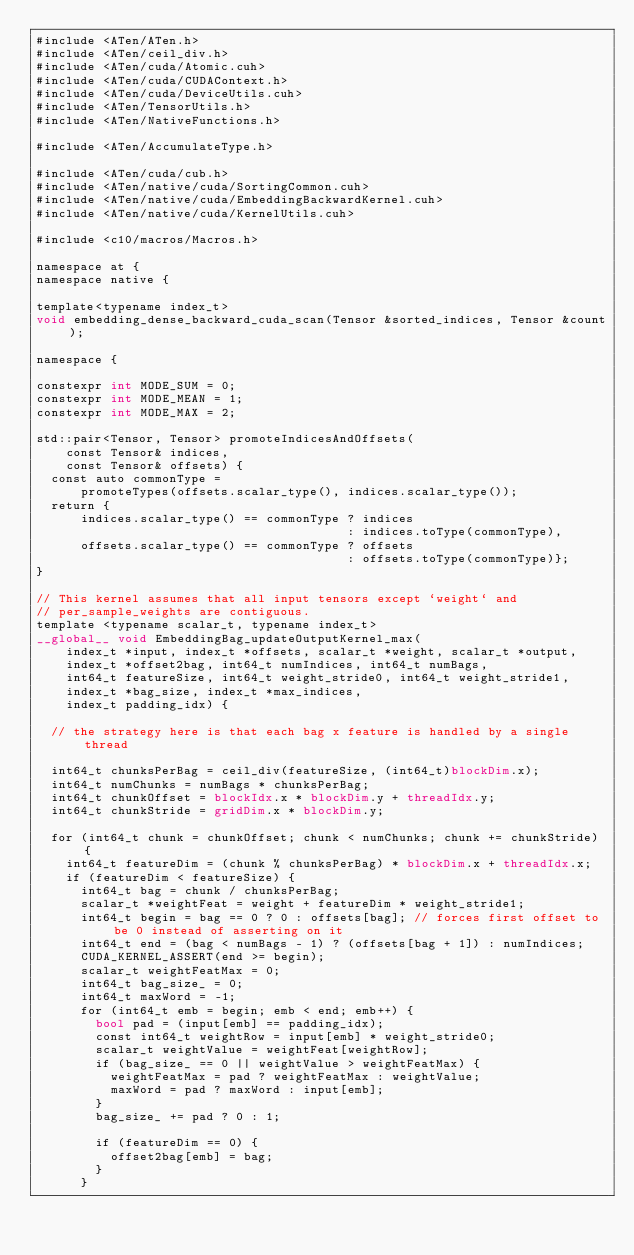<code> <loc_0><loc_0><loc_500><loc_500><_Cuda_>#include <ATen/ATen.h>
#include <ATen/ceil_div.h>
#include <ATen/cuda/Atomic.cuh>
#include <ATen/cuda/CUDAContext.h>
#include <ATen/cuda/DeviceUtils.cuh>
#include <ATen/TensorUtils.h>
#include <ATen/NativeFunctions.h>

#include <ATen/AccumulateType.h>

#include <ATen/cuda/cub.h>
#include <ATen/native/cuda/SortingCommon.cuh>
#include <ATen/native/cuda/EmbeddingBackwardKernel.cuh>
#include <ATen/native/cuda/KernelUtils.cuh>

#include <c10/macros/Macros.h>

namespace at {
namespace native {

template<typename index_t>
void embedding_dense_backward_cuda_scan(Tensor &sorted_indices, Tensor &count);

namespace {

constexpr int MODE_SUM = 0;
constexpr int MODE_MEAN = 1;
constexpr int MODE_MAX = 2;

std::pair<Tensor, Tensor> promoteIndicesAndOffsets(
    const Tensor& indices,
    const Tensor& offsets) {
  const auto commonType =
      promoteTypes(offsets.scalar_type(), indices.scalar_type());
  return {
      indices.scalar_type() == commonType ? indices
                                          : indices.toType(commonType),
      offsets.scalar_type() == commonType ? offsets
                                          : offsets.toType(commonType)};
}

// This kernel assumes that all input tensors except `weight` and
// per_sample_weights are contiguous.
template <typename scalar_t, typename index_t>
__global__ void EmbeddingBag_updateOutputKernel_max(
    index_t *input, index_t *offsets, scalar_t *weight, scalar_t *output,
    index_t *offset2bag, int64_t numIndices, int64_t numBags,
    int64_t featureSize, int64_t weight_stride0, int64_t weight_stride1,
    index_t *bag_size, index_t *max_indices,
    index_t padding_idx) {

  // the strategy here is that each bag x feature is handled by a single thread

  int64_t chunksPerBag = ceil_div(featureSize, (int64_t)blockDim.x);
  int64_t numChunks = numBags * chunksPerBag;
  int64_t chunkOffset = blockIdx.x * blockDim.y + threadIdx.y;
  int64_t chunkStride = gridDim.x * blockDim.y;

  for (int64_t chunk = chunkOffset; chunk < numChunks; chunk += chunkStride) {
    int64_t featureDim = (chunk % chunksPerBag) * blockDim.x + threadIdx.x;
    if (featureDim < featureSize) {
      int64_t bag = chunk / chunksPerBag;
      scalar_t *weightFeat = weight + featureDim * weight_stride1;
      int64_t begin = bag == 0 ? 0 : offsets[bag]; // forces first offset to be 0 instead of asserting on it
      int64_t end = (bag < numBags - 1) ? (offsets[bag + 1]) : numIndices;
      CUDA_KERNEL_ASSERT(end >= begin);
      scalar_t weightFeatMax = 0;
      int64_t bag_size_ = 0;
      int64_t maxWord = -1;
      for (int64_t emb = begin; emb < end; emb++) {
        bool pad = (input[emb] == padding_idx);
        const int64_t weightRow = input[emb] * weight_stride0;
        scalar_t weightValue = weightFeat[weightRow];
        if (bag_size_ == 0 || weightValue > weightFeatMax) {
          weightFeatMax = pad ? weightFeatMax : weightValue;
          maxWord = pad ? maxWord : input[emb];
        }
        bag_size_ += pad ? 0 : 1;

        if (featureDim == 0) {
          offset2bag[emb] = bag;
        }
      }</code> 